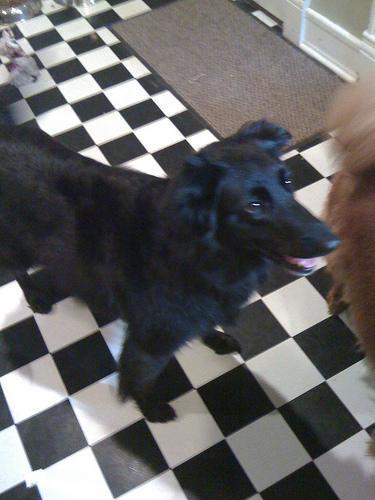How many black dogs are there?
Give a very brief answer. 1. 